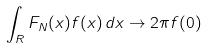Convert formula to latex. <formula><loc_0><loc_0><loc_500><loc_500>\int _ { R } F _ { N } ( x ) f ( x ) \, d x \to 2 \pi f ( 0 )</formula> 